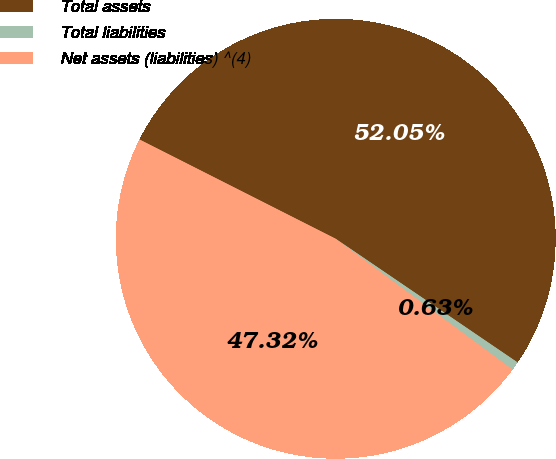Convert chart. <chart><loc_0><loc_0><loc_500><loc_500><pie_chart><fcel>Total assets<fcel>Total liabilities<fcel>Net assets (liabilities) ^(4)<nl><fcel>52.05%<fcel>0.63%<fcel>47.32%<nl></chart> 